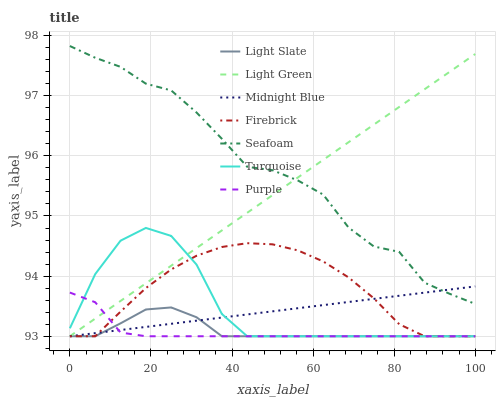Does Purple have the minimum area under the curve?
Answer yes or no. Yes. Does Seafoam have the maximum area under the curve?
Answer yes or no. Yes. Does Midnight Blue have the minimum area under the curve?
Answer yes or no. No. Does Midnight Blue have the maximum area under the curve?
Answer yes or no. No. Is Light Green the smoothest?
Answer yes or no. Yes. Is Seafoam the roughest?
Answer yes or no. Yes. Is Midnight Blue the smoothest?
Answer yes or no. No. Is Midnight Blue the roughest?
Answer yes or no. No. Does Turquoise have the lowest value?
Answer yes or no. Yes. Does Seafoam have the lowest value?
Answer yes or no. No. Does Seafoam have the highest value?
Answer yes or no. Yes. Does Midnight Blue have the highest value?
Answer yes or no. No. Is Firebrick less than Seafoam?
Answer yes or no. Yes. Is Seafoam greater than Firebrick?
Answer yes or no. Yes. Does Firebrick intersect Turquoise?
Answer yes or no. Yes. Is Firebrick less than Turquoise?
Answer yes or no. No. Is Firebrick greater than Turquoise?
Answer yes or no. No. Does Firebrick intersect Seafoam?
Answer yes or no. No. 